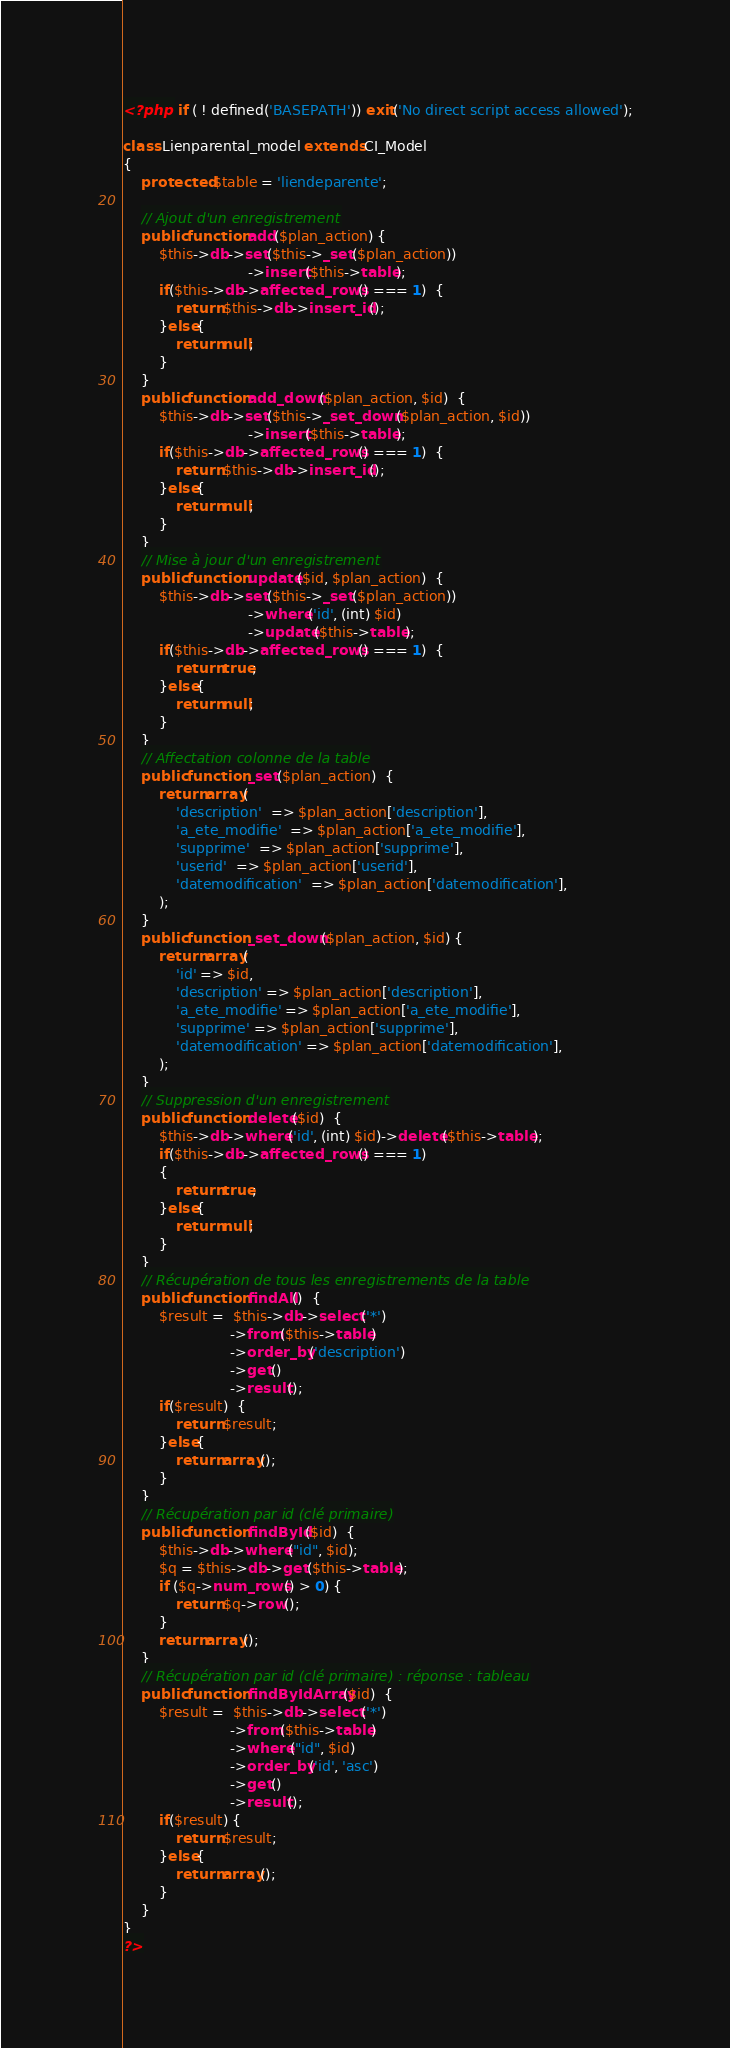<code> <loc_0><loc_0><loc_500><loc_500><_PHP_><?php  if ( ! defined('BASEPATH')) exit('No direct script access allowed');

class Lienparental_model extends CI_Model
{
    protected $table = 'liendeparente';

	// Ajout d'un enregistrement
    public function add($plan_action) {
        $this->db->set($this->_set($plan_action))
                            ->insert($this->table);
        if($this->db->affected_rows() === 1)  {
            return $this->db->insert_id();
        }else{
            return null;
        }                    
    }
    public function add_down($plan_action, $id)  {
        $this->db->set($this->_set_down($plan_action, $id))
                            ->insert($this->table);
        if($this->db->affected_rows() === 1)  {
            return $this->db->insert_id();
        }else{
            return null;
        }                    
    }
	// Mise à jour d'un enregistrement
    public function update($id, $plan_action)  {
        $this->db->set($this->_set($plan_action))
                            ->where('id', (int) $id)
                            ->update($this->table);
        if($this->db->affected_rows() === 1)  {
            return true;
        }else{
            return null;
        }                      
    }
	// Affectation colonne de la table
    public function _set($plan_action)  {
        return array(
            'description'  => $plan_action['description'],
            'a_ete_modifie'  => $plan_action['a_ete_modifie'],
            'supprime'  => $plan_action['supprime'],
            'userid'  => $plan_action['userid'],
            'datemodification'  => $plan_action['datemodification'],
        );
    }
    public function _set_down($plan_action, $id) {
        return array(
            'id' => $id,
            'description' => $plan_action['description'],
            'a_ete_modifie' => $plan_action['a_ete_modifie'],
            'supprime' => $plan_action['supprime'],
            'datemodification' => $plan_action['datemodification'],
        );
    }
	// Suppression d'un enregistrement
    public function delete($id)  {
        $this->db->where('id', (int) $id)->delete($this->table);
        if($this->db->affected_rows() === 1)
        {
            return true;
        }else{
            return null;
        }  
    }
	// Récupération de tous les enregistrements de la table
    public function findAll()  {
        $result =  $this->db->select('*')
                        ->from($this->table)
                        ->order_by('description')
                        ->get()
                        ->result();
        if($result)  {
            return $result;
        }else{
            return array();
        }                 
    }
	// Récupération par id (clé primaire)
    public function findById($id)  {
        $this->db->where("id", $id);
        $q = $this->db->get($this->table);
        if ($q->num_rows() > 0) {
            return $q->row();
        }
        return array();
    }
	// Récupération par id (clé primaire) : réponse : tableau
    public function findByIdArray($id)  {
        $result =  $this->db->select('*')
                        ->from($this->table)
                        ->where("id", $id)
                        ->order_by('id', 'asc')
                        ->get()
                        ->result();
        if($result) {
            return $result;
        }else{
            return array();
        }                 
    }
}
?></code> 